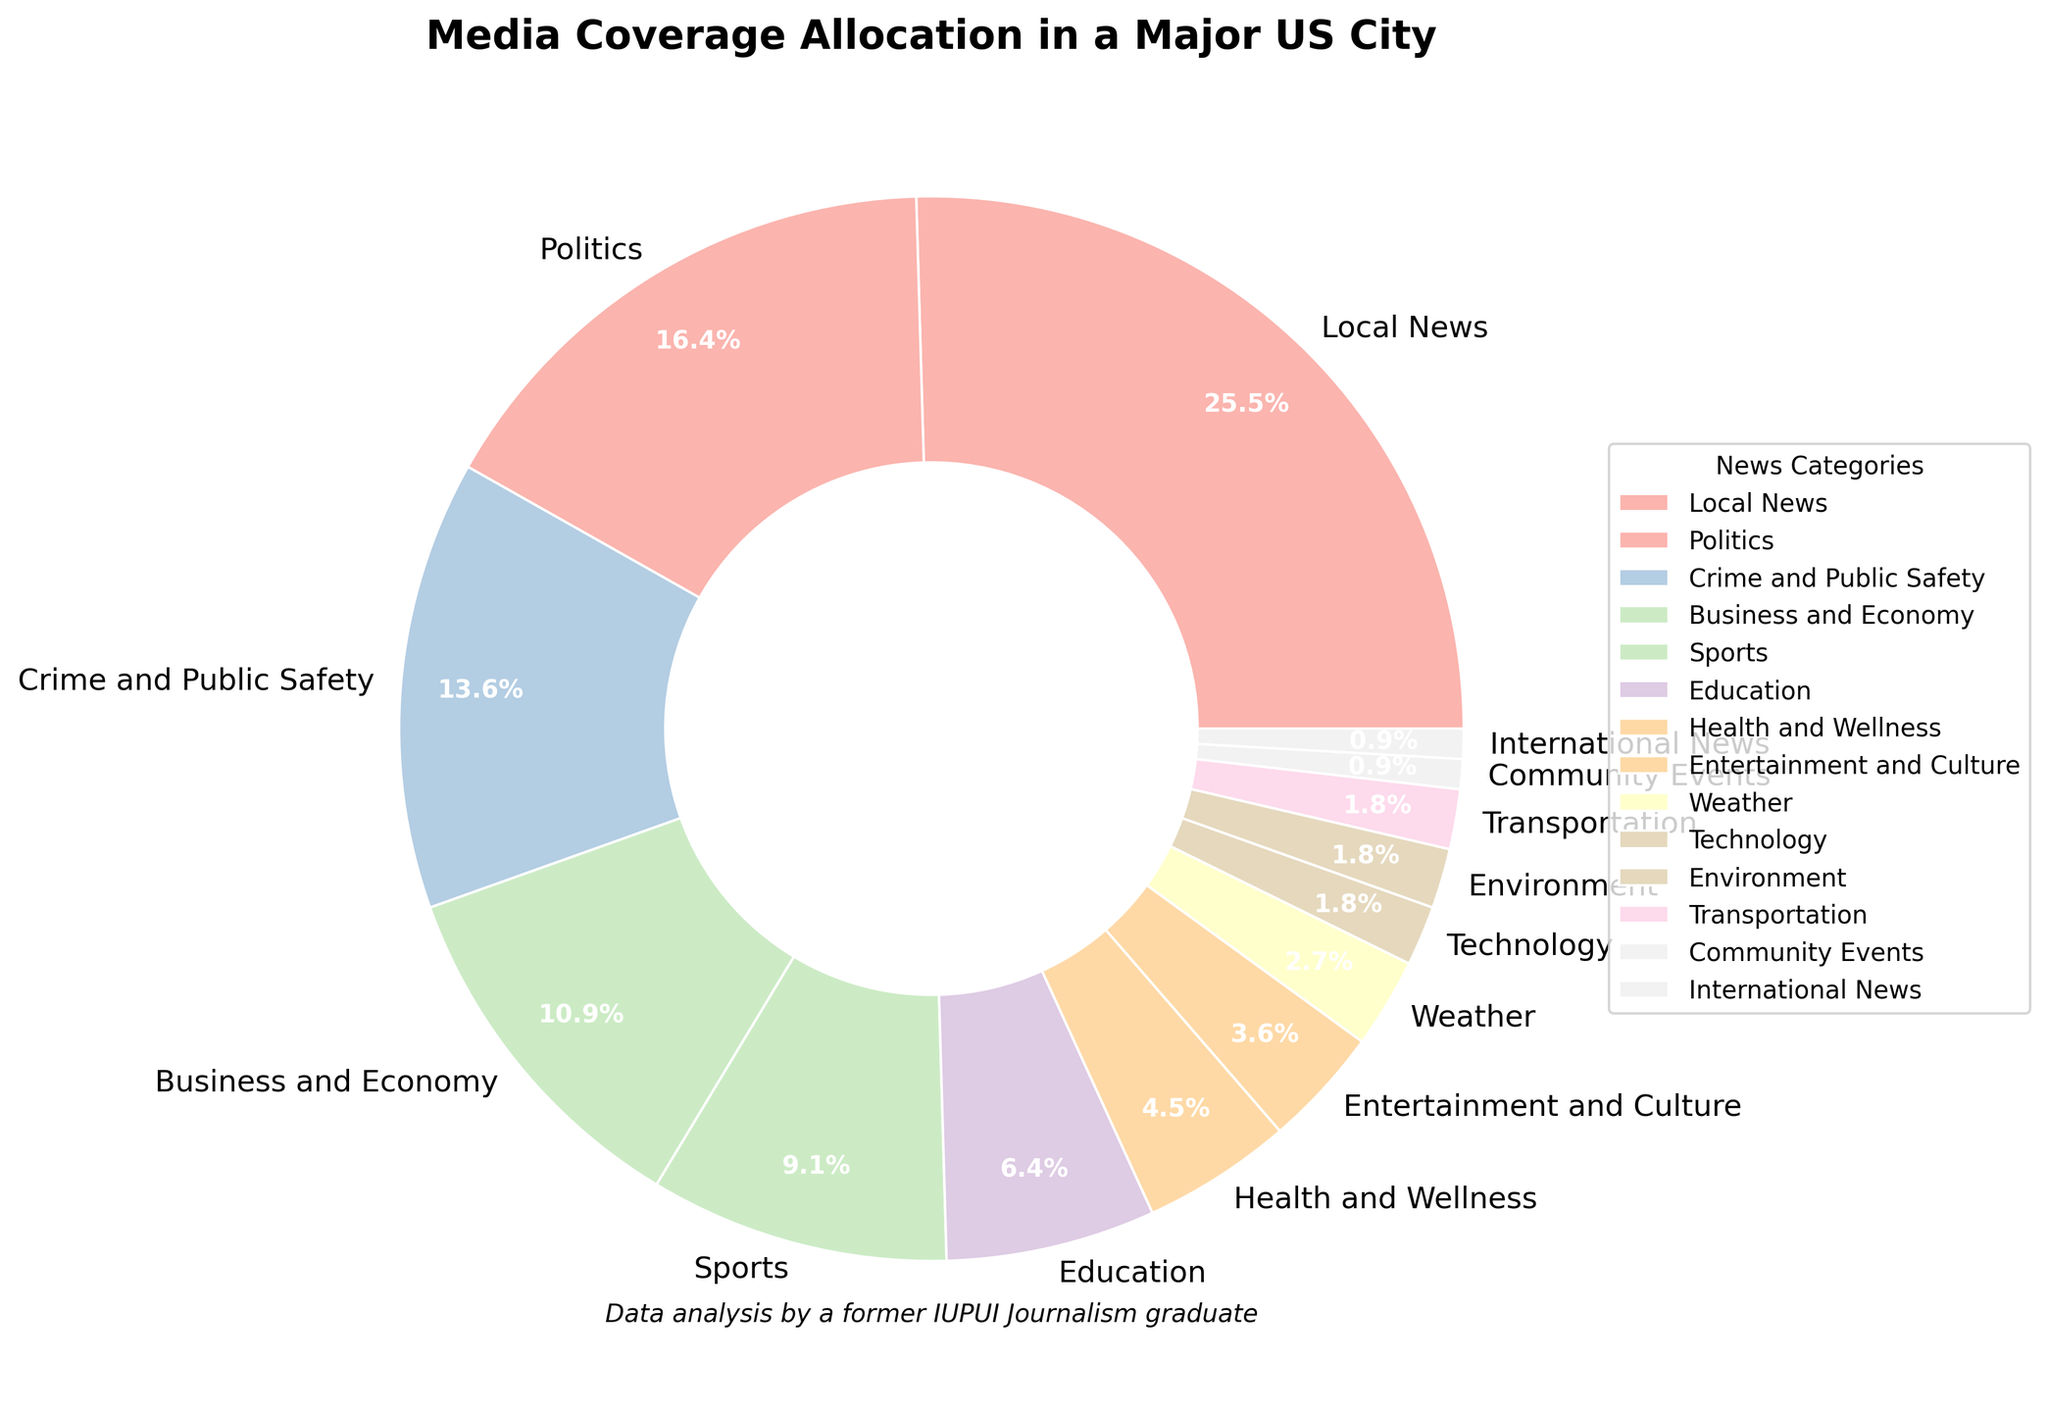What percentage of the pie chart is allocated to "Local News"? Find the slice labeled "Local News" in the chart and read its corresponding percentage.
Answer: 28% Which category receives more coverage: "Education" or "Health and Wellness"? Locate the slices labeled "Education" and "Health and Wellness." Compare their percentages.
Answer: Education What is the total percentage of coverage for "Business and Economy," "Sports," and "Education" combined? Sum the percentages of "Business and Economy" (12%), "Sports" (10%), and "Education" (7%). Calculate 12 + 10 + 7.
Answer: 29% Out of "Politics" and "Crime and Public Safety," which receives less media coverage? Locate the slices for "Politics" (18%) and "Crime and Public Safety" (15%) and compare their values.
Answer: Crime and Public Safety Which categories have an equal percentage of coverage, and what is that percentage? Identify categories with the same percentage value. "Technology," "Environment," and "Transportation" all have 2%.
Answer: Technology, Environment, Transportation, 2% How much more coverage does "Local News" receive compared to "Sports"? Subtract the percentage of "Sports" (10%) from the percentage of "Local News" (28%). Calculate 28 - 10.
Answer: 18% What is the combined percentage for categories with less than 5% coverage each? Identify categories under 5%: "Entertainment and Culture" (4%), "Weather" (3%), "Technology" (2%), "Environment" (2%), "Transportation" (2%), "Community Events" (1%), "International News" (1%). Sum these values: 4 + 3 + 2 + 2 + 2 + 1 + 1.
Answer: 15% Compare the media coverage of "Business and Economy" and "Entertainment and Culture." How many times greater is the coverage for "Business and Economy" compared to "Entertainment and Culture"? Divide the percentage of "Business and Economy" (12%) by the percentage of "Entertainment and Culture" (4%). Calculate 12 / 4.
Answer: 3 times Which category receives the least media coverage, and what is its percentage? Find the smallest percentage in the chart, which is labeled "International News" (1%).
Answer: International News, 1% How many categories have a coverage percentage greater than or equal to 10%? Identify and count categories with percentages 10% or higher: "Local News" (28%), "Politics" (18%), "Crime and Public Safety" (15%), "Business and Economy" (12%), "Sports" (10%).
Answer: 5 